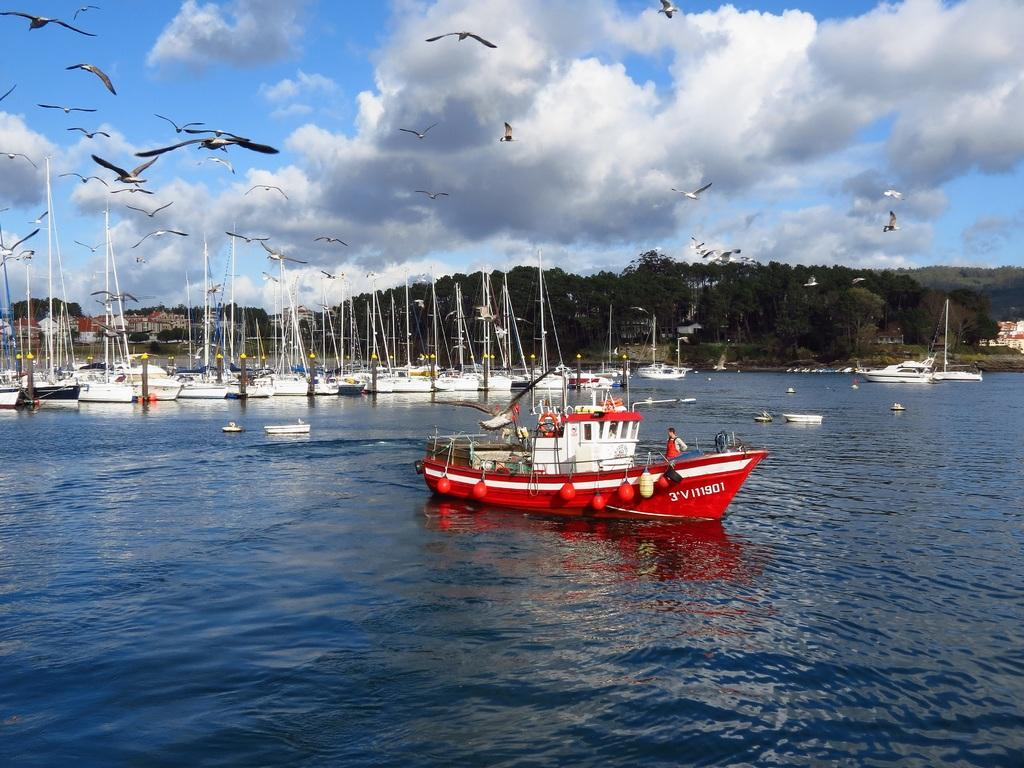What is the main subject of the image? The main subject of the image is a group of boats. Where are the boats located? The boats are on water. What can be seen in the background of the image? There are trees and the sky visible in the background of the image. Are there any animals present in the image? Yes, birds are flying in the background of the image. What type of holiday is being celebrated in the image? There is no indication of a holiday being celebrated in the image; it features a group of boats on water with birds flying in the background. 